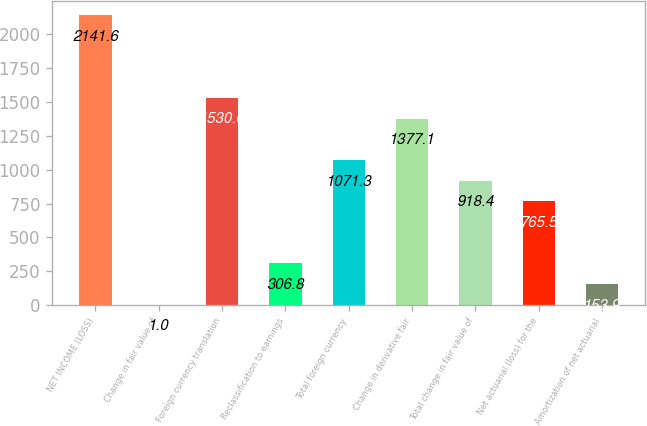Convert chart to OTSL. <chart><loc_0><loc_0><loc_500><loc_500><bar_chart><fcel>NET INCOME (LOSS)<fcel>Change in fair value of<fcel>Foreign currency translation<fcel>Reclassification to earnings<fcel>Total foreign currency<fcel>Change in derivative fair<fcel>Total change in fair value of<fcel>Net actuarial (loss) for the<fcel>Amortization of net actuarial<nl><fcel>2141.6<fcel>1<fcel>1530<fcel>306.8<fcel>1071.3<fcel>1377.1<fcel>918.4<fcel>765.5<fcel>153.9<nl></chart> 